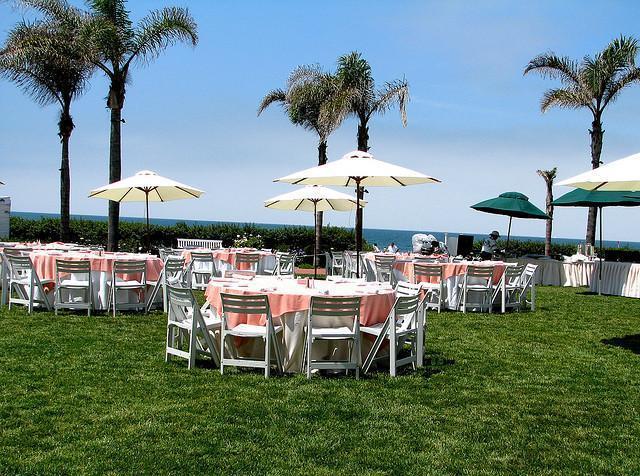How many dining tables can be seen?
Give a very brief answer. 2. How many chairs are there?
Give a very brief answer. 5. How many umbrellas are there?
Give a very brief answer. 3. How many elephants are standing near the grass?
Give a very brief answer. 0. 